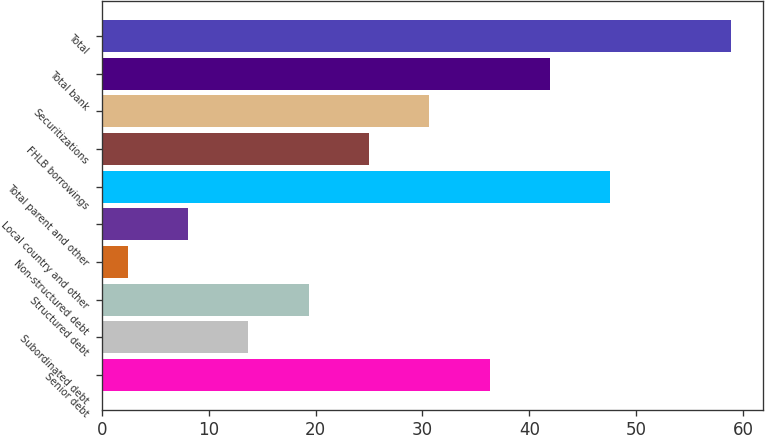<chart> <loc_0><loc_0><loc_500><loc_500><bar_chart><fcel>Senior debt<fcel>Subordinated debt<fcel>Structured debt<fcel>Non-structured debt<fcel>Local country and other<fcel>Total parent and other<fcel>FHLB borrowings<fcel>Securitizations<fcel>Total bank<fcel>Total<nl><fcel>36.3<fcel>13.7<fcel>19.35<fcel>2.4<fcel>8.05<fcel>47.6<fcel>25<fcel>30.65<fcel>41.95<fcel>58.9<nl></chart> 